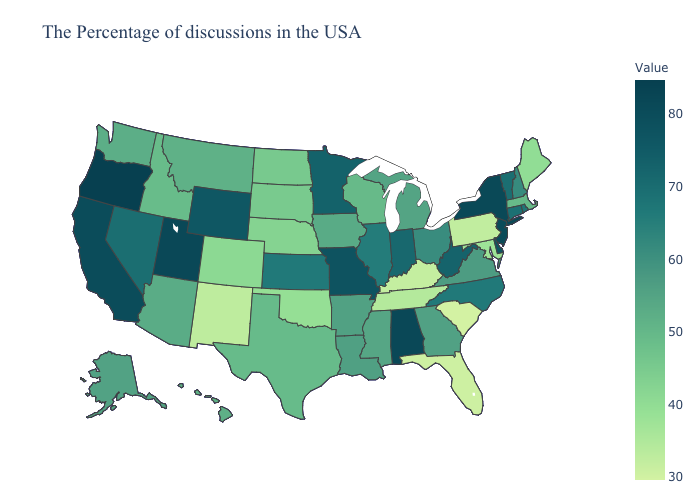Which states have the lowest value in the USA?
Short answer required. South Carolina. Among the states that border Wisconsin , which have the lowest value?
Give a very brief answer. Iowa. Which states have the lowest value in the Northeast?
Short answer required. Pennsylvania. Is the legend a continuous bar?
Concise answer only. Yes. Does Oregon have a lower value than Delaware?
Short answer required. No. Does New Hampshire have the lowest value in the Northeast?
Write a very short answer. No. 